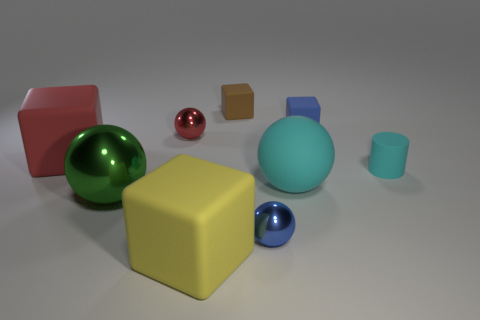Is there anything else that is the same size as the cyan cylinder?
Ensure brevity in your answer.  Yes. What is the color of the cylinder that is made of the same material as the cyan ball?
Give a very brief answer. Cyan. There is a object that is both right of the big cyan rubber sphere and left of the matte cylinder; what is its size?
Make the answer very short. Small. Are there fewer small brown rubber objects that are to the left of the large cyan sphere than red rubber things that are to the right of the big metallic sphere?
Offer a very short reply. No. Are the tiny ball on the right side of the brown cube and the large block that is in front of the large red rubber cube made of the same material?
Offer a very short reply. No. There is a tiny matte object that is on the left side of the small cyan thing and in front of the tiny brown rubber object; what shape is it?
Provide a succinct answer. Cube. The big sphere left of the small metallic sphere in front of the tiny red metallic object is made of what material?
Provide a short and direct response. Metal. Is the number of large green metal objects greater than the number of large cyan metal balls?
Offer a terse response. Yes. Do the matte ball and the cylinder have the same color?
Keep it short and to the point. Yes. What material is the red object that is the same size as the brown matte block?
Your response must be concise. Metal. 